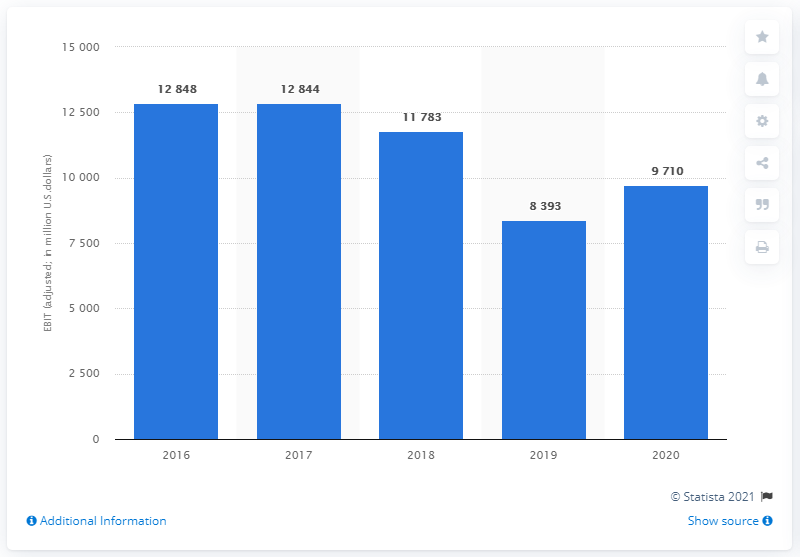Mention a couple of crucial points in this snapshot. In 2020, General Motors (GM) reported earnings before interest and taxes (EBIT) of $9710. 